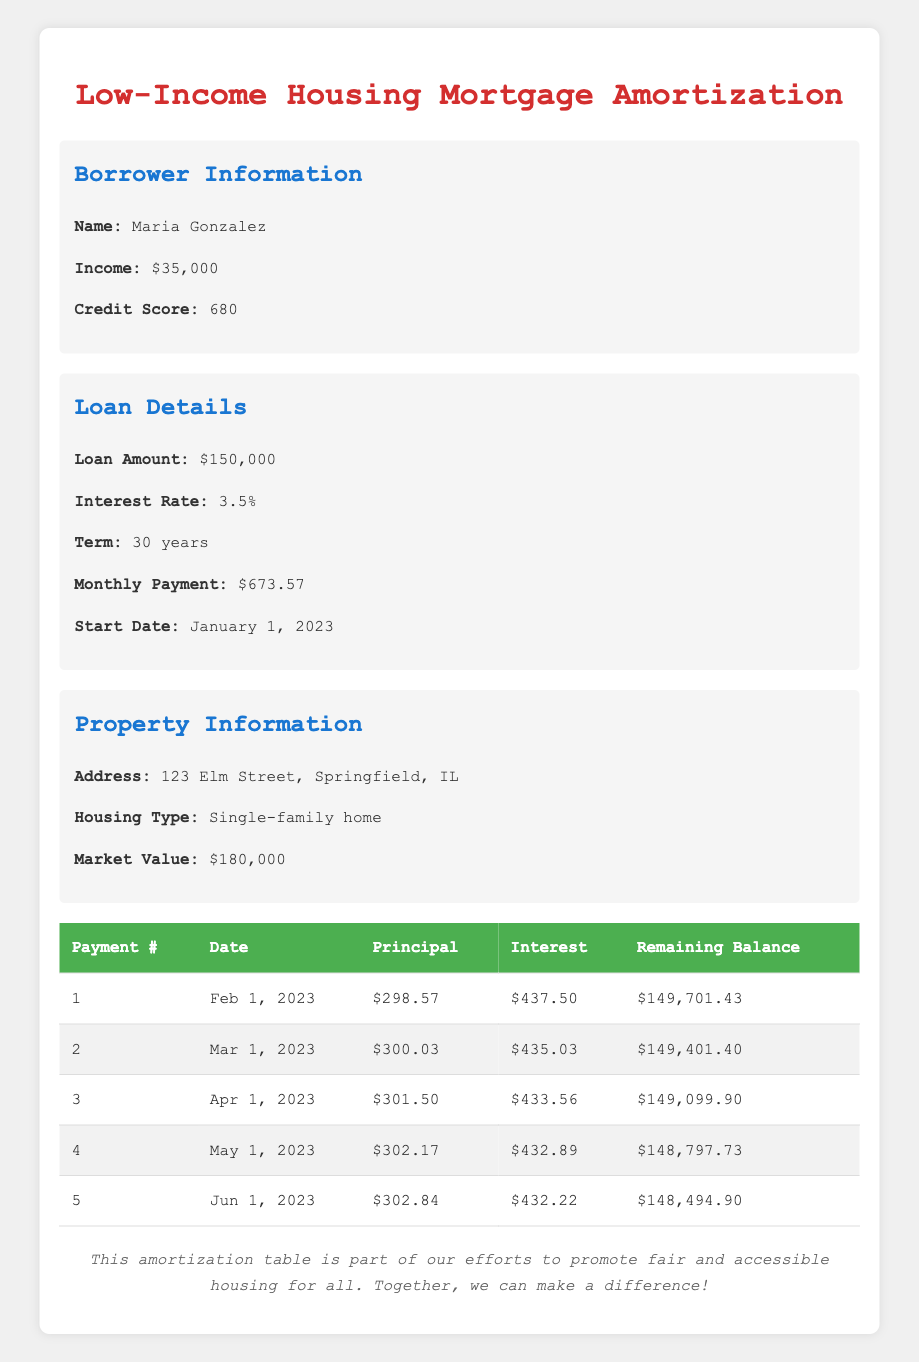What is the monthly payment amount for the mortgage? The monthly payment amount is listed in the loan details section of the table, specifically stated as $673.57.
Answer: 673.57 How much was the initial loan amount? The initial loan amount can be found in the loan details section of the table, which shows the loan amount as $150,000.
Answer: 150000 Did Maria's monthly principal payment increase from the first to the fifth payment? By comparing the principal payments for the first and fifth payments, we see that the first payment is $298.57 and the fifth is $302.84. Since $302.84 is greater than $298.57, the answer is yes.
Answer: Yes What is the total interest paid in the first five months? To find the total interest paid, we sum the interest payments for each of the first five months: $437.50 + $435.03 + $433.56 + $432.89 + $432.22 = $2,170.20.
Answer: 2170.20 What is the remaining balance after the fourth payment? The remaining balance after the fourth payment is directly listed in the table, which states it is $148,797.73 for the fourth payment.
Answer: 148797.73 How much total principal has been paid after 5 payments? To compute the total principal paid after five payments, we sum the principal payments: $298.57 + $300.03 + $301.50 + $302.17 + $302.84 = $1,504.11.
Answer: 1504.11 Is the housing market value higher than the loan amount? By comparing the market value of the property at $180,000 with the loan amount of $150,000, we see that $180,000 is greater than $150,000, thus the answer is yes.
Answer: Yes What is the average principal payment across the first five months? The average principal payment is calculated by summing the principal payments and dividing by the number of payments: ($298.57 + $300.03 + $301.50 + $302.17 + $302.84) / 5 = $300.82.
Answer: 300.82 How much did the interest payment decrease after the first payment? The interest payment for the first payment is $437.50, and for the second payment, it is $435.03. The decrease is $437.50 - $435.03 = $2.47.
Answer: 2.47 